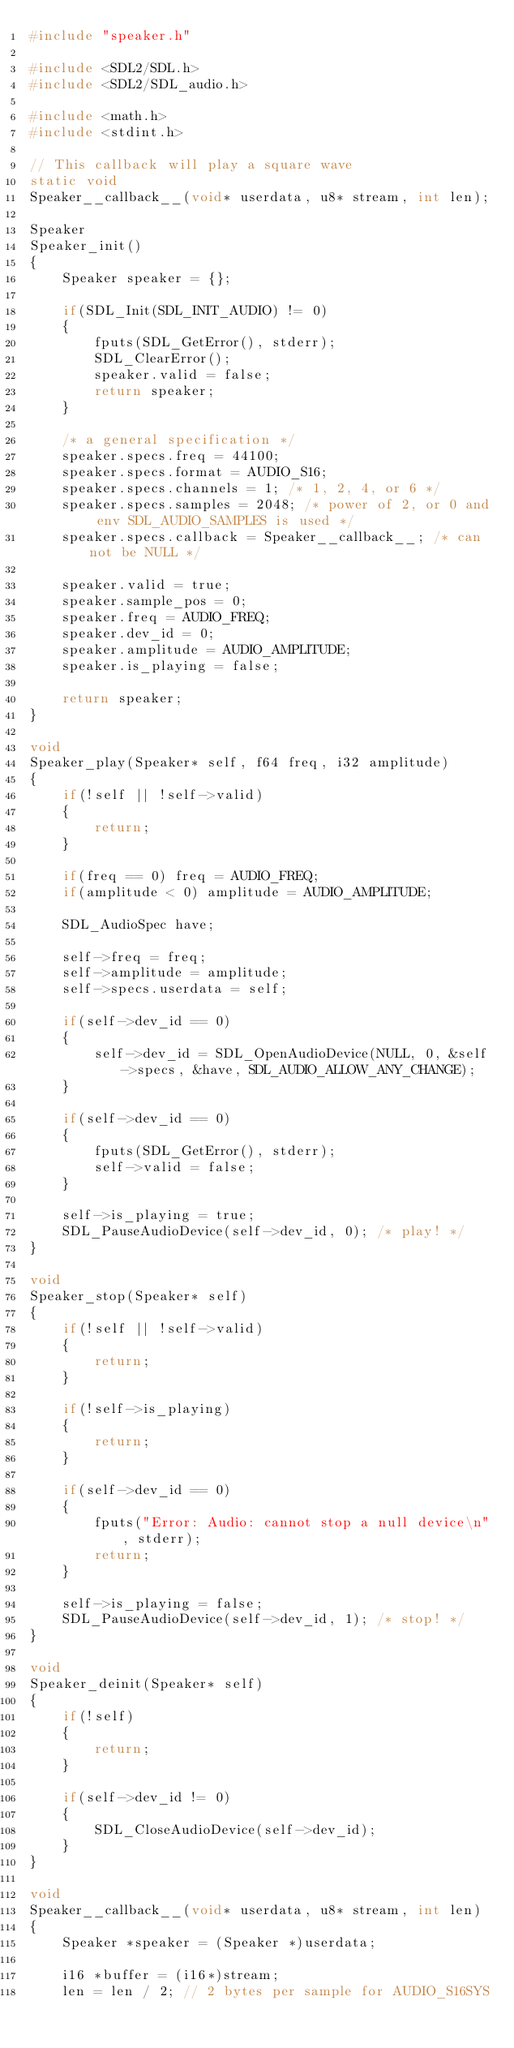<code> <loc_0><loc_0><loc_500><loc_500><_C_>#include "speaker.h"

#include <SDL2/SDL.h>
#include <SDL2/SDL_audio.h>

#include <math.h>
#include <stdint.h>

// This callback will play a square wave
static void
Speaker__callback__(void* userdata, u8* stream, int len);

Speaker
Speaker_init()
{
    Speaker speaker = {};

    if(SDL_Init(SDL_INIT_AUDIO) != 0)
    {
        fputs(SDL_GetError(), stderr);
        SDL_ClearError();
        speaker.valid = false;
        return speaker;
    }

    /* a general specification */
    speaker.specs.freq = 44100;
    speaker.specs.format = AUDIO_S16;
    speaker.specs.channels = 1; /* 1, 2, 4, or 6 */
    speaker.specs.samples = 2048; /* power of 2, or 0 and env SDL_AUDIO_SAMPLES is used */
    speaker.specs.callback = Speaker__callback__; /* can not be NULL */

    speaker.valid = true;
    speaker.sample_pos = 0;
    speaker.freq = AUDIO_FREQ;
    speaker.dev_id = 0;
    speaker.amplitude = AUDIO_AMPLITUDE;
    speaker.is_playing = false;

    return speaker;
}

void
Speaker_play(Speaker* self, f64 freq, i32 amplitude)
{
    if(!self || !self->valid)
    {
        return;
    }

    if(freq == 0) freq = AUDIO_FREQ;
    if(amplitude < 0) amplitude = AUDIO_AMPLITUDE;

    SDL_AudioSpec have;

    self->freq = freq;
    self->amplitude = amplitude;
    self->specs.userdata = self;

    if(self->dev_id == 0)
    {
        self->dev_id = SDL_OpenAudioDevice(NULL, 0, &self->specs, &have, SDL_AUDIO_ALLOW_ANY_CHANGE);
    }

    if(self->dev_id == 0)
    {
        fputs(SDL_GetError(), stderr);
        self->valid = false;
    }

    self->is_playing = true;
    SDL_PauseAudioDevice(self->dev_id, 0); /* play! */
}

void
Speaker_stop(Speaker* self)
{
    if(!self || !self->valid)
    {
        return;
    }

    if(!self->is_playing)
    {
        return;
    }

    if(self->dev_id == 0)
    {
        fputs("Error: Audio: cannot stop a null device\n", stderr);
        return;
    }

    self->is_playing = false;
    SDL_PauseAudioDevice(self->dev_id, 1); /* stop! */
}

void
Speaker_deinit(Speaker* self)
{
    if(!self)
    {
        return;
    }

    if(self->dev_id != 0)
    {
        SDL_CloseAudioDevice(self->dev_id);
    }
}

void
Speaker__callback__(void* userdata, u8* stream, int len)
{
    Speaker *speaker = (Speaker *)userdata;

    i16 *buffer = (i16*)stream;
    len = len / 2; // 2 bytes per sample for AUDIO_S16SYS
</code> 